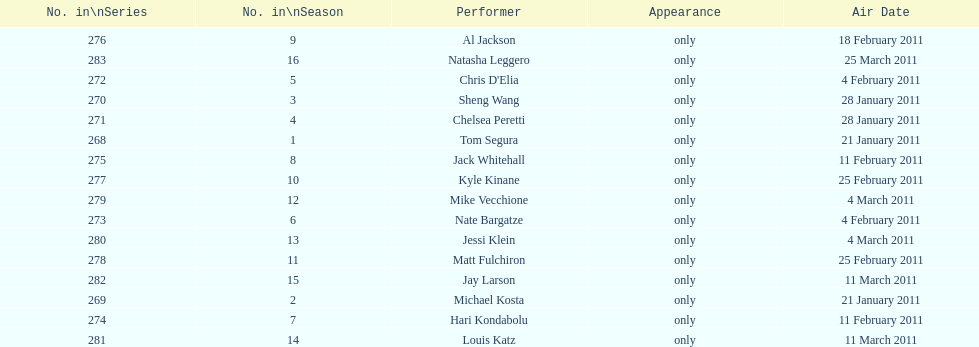What was the total count of air dates in february? 7. Help me parse the entirety of this table. {'header': ['No. in\\nSeries', 'No. in\\nSeason', 'Performer', 'Appearance', 'Air Date'], 'rows': [['276', '9', 'Al Jackson', 'only', '18 February 2011'], ['283', '16', 'Natasha Leggero', 'only', '25 March 2011'], ['272', '5', "Chris D'Elia", 'only', '4 February 2011'], ['270', '3', 'Sheng Wang', 'only', '28 January 2011'], ['271', '4', 'Chelsea Peretti', 'only', '28 January 2011'], ['268', '1', 'Tom Segura', 'only', '21 January 2011'], ['275', '8', 'Jack Whitehall', 'only', '11 February 2011'], ['277', '10', 'Kyle Kinane', 'only', '25 February 2011'], ['279', '12', 'Mike Vecchione', 'only', '4 March 2011'], ['273', '6', 'Nate Bargatze', 'only', '4 February 2011'], ['280', '13', 'Jessi Klein', 'only', '4 March 2011'], ['278', '11', 'Matt Fulchiron', 'only', '25 February 2011'], ['282', '15', 'Jay Larson', 'only', '11 March 2011'], ['269', '2', 'Michael Kosta', 'only', '21 January 2011'], ['274', '7', 'Hari Kondabolu', 'only', '11 February 2011'], ['281', '14', 'Louis Katz', 'only', '11 March 2011']]} 